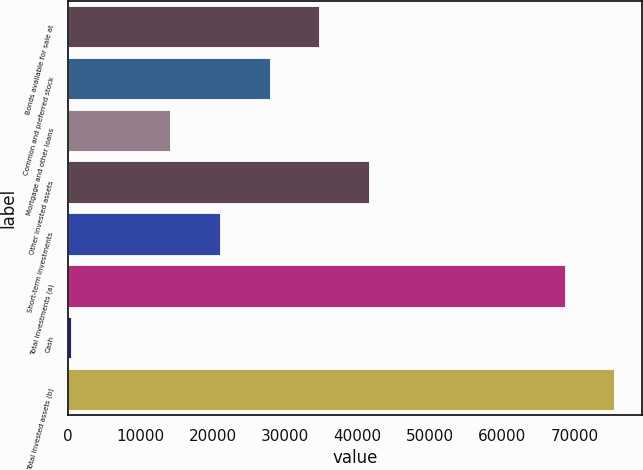Convert chart to OTSL. <chart><loc_0><loc_0><loc_500><loc_500><bar_chart><fcel>Bonds available for sale at<fcel>Common and preferred stock<fcel>Mortgage and other loans<fcel>Other invested assets<fcel>Short-term investments<fcel>Total investments (a)<fcel>Cash<fcel>Total invested assets (b)<nl><fcel>34723.5<fcel>27861.6<fcel>14137.8<fcel>41585.4<fcel>20999.7<fcel>68619<fcel>414<fcel>75480.9<nl></chart> 